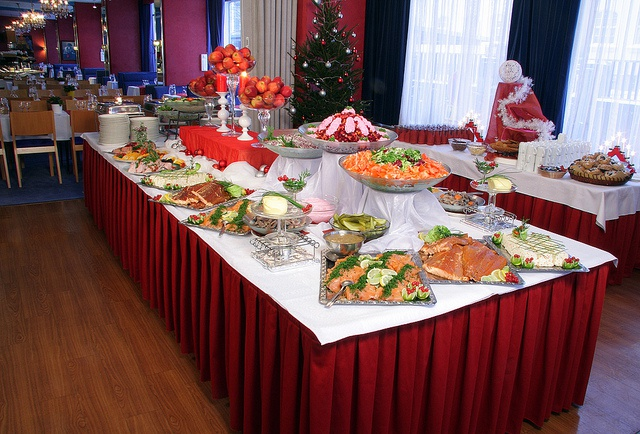Describe the objects in this image and their specific colors. I can see dining table in darkblue, maroon, lightgray, black, and darkgray tones, dining table in darkblue, maroon, darkgray, black, and lightgray tones, potted plant in darkblue, black, maroon, gray, and brown tones, bowl in darkblue, salmon, darkgray, red, and brown tones, and bowl in navy, pink, darkgray, brown, and maroon tones in this image. 